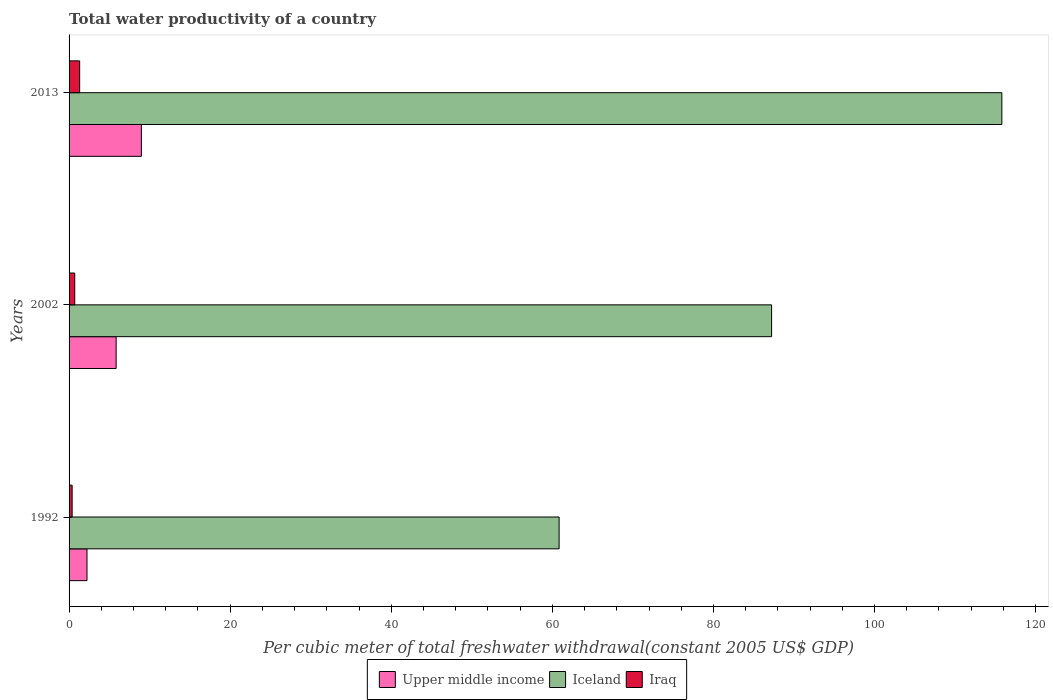How many groups of bars are there?
Your answer should be very brief. 3. Are the number of bars per tick equal to the number of legend labels?
Keep it short and to the point. Yes. Are the number of bars on each tick of the Y-axis equal?
Offer a terse response. Yes. How many bars are there on the 3rd tick from the top?
Ensure brevity in your answer.  3. What is the label of the 3rd group of bars from the top?
Your answer should be very brief. 1992. In how many cases, is the number of bars for a given year not equal to the number of legend labels?
Offer a terse response. 0. What is the total water productivity in Iraq in 2002?
Your answer should be very brief. 0.7. Across all years, what is the maximum total water productivity in Iraq?
Give a very brief answer. 1.31. Across all years, what is the minimum total water productivity in Iceland?
Your response must be concise. 60.84. In which year was the total water productivity in Iraq maximum?
Offer a terse response. 2013. What is the total total water productivity in Iceland in the graph?
Make the answer very short. 263.86. What is the difference between the total water productivity in Iceland in 1992 and that in 2002?
Provide a short and direct response. -26.38. What is the difference between the total water productivity in Iraq in 1992 and the total water productivity in Iceland in 2002?
Provide a succinct answer. -86.84. What is the average total water productivity in Iraq per year?
Offer a very short reply. 0.8. In the year 1992, what is the difference between the total water productivity in Iraq and total water productivity in Upper middle income?
Ensure brevity in your answer.  -1.85. In how many years, is the total water productivity in Iraq greater than 104 US$?
Offer a very short reply. 0. What is the ratio of the total water productivity in Upper middle income in 1992 to that in 2002?
Ensure brevity in your answer.  0.38. Is the total water productivity in Iraq in 1992 less than that in 2002?
Keep it short and to the point. Yes. What is the difference between the highest and the second highest total water productivity in Iceland?
Your response must be concise. 28.59. What is the difference between the highest and the lowest total water productivity in Iceland?
Make the answer very short. 54.97. What does the 2nd bar from the bottom in 1992 represents?
Make the answer very short. Iceland. Is it the case that in every year, the sum of the total water productivity in Iraq and total water productivity in Iceland is greater than the total water productivity in Upper middle income?
Provide a short and direct response. Yes. Are all the bars in the graph horizontal?
Provide a succinct answer. Yes. How many years are there in the graph?
Your response must be concise. 3. Are the values on the major ticks of X-axis written in scientific E-notation?
Provide a short and direct response. No. Does the graph contain any zero values?
Your answer should be compact. No. How many legend labels are there?
Give a very brief answer. 3. How are the legend labels stacked?
Make the answer very short. Horizontal. What is the title of the graph?
Provide a short and direct response. Total water productivity of a country. What is the label or title of the X-axis?
Your answer should be very brief. Per cubic meter of total freshwater withdrawal(constant 2005 US$ GDP). What is the Per cubic meter of total freshwater withdrawal(constant 2005 US$ GDP) of Upper middle income in 1992?
Ensure brevity in your answer.  2.23. What is the Per cubic meter of total freshwater withdrawal(constant 2005 US$ GDP) in Iceland in 1992?
Ensure brevity in your answer.  60.84. What is the Per cubic meter of total freshwater withdrawal(constant 2005 US$ GDP) in Iraq in 1992?
Provide a succinct answer. 0.38. What is the Per cubic meter of total freshwater withdrawal(constant 2005 US$ GDP) in Upper middle income in 2002?
Keep it short and to the point. 5.84. What is the Per cubic meter of total freshwater withdrawal(constant 2005 US$ GDP) in Iceland in 2002?
Your response must be concise. 87.22. What is the Per cubic meter of total freshwater withdrawal(constant 2005 US$ GDP) of Iraq in 2002?
Provide a succinct answer. 0.7. What is the Per cubic meter of total freshwater withdrawal(constant 2005 US$ GDP) in Upper middle income in 2013?
Provide a short and direct response. 8.98. What is the Per cubic meter of total freshwater withdrawal(constant 2005 US$ GDP) in Iceland in 2013?
Your answer should be very brief. 115.81. What is the Per cubic meter of total freshwater withdrawal(constant 2005 US$ GDP) of Iraq in 2013?
Make the answer very short. 1.31. Across all years, what is the maximum Per cubic meter of total freshwater withdrawal(constant 2005 US$ GDP) in Upper middle income?
Offer a very short reply. 8.98. Across all years, what is the maximum Per cubic meter of total freshwater withdrawal(constant 2005 US$ GDP) of Iceland?
Make the answer very short. 115.81. Across all years, what is the maximum Per cubic meter of total freshwater withdrawal(constant 2005 US$ GDP) of Iraq?
Offer a very short reply. 1.31. Across all years, what is the minimum Per cubic meter of total freshwater withdrawal(constant 2005 US$ GDP) in Upper middle income?
Ensure brevity in your answer.  2.23. Across all years, what is the minimum Per cubic meter of total freshwater withdrawal(constant 2005 US$ GDP) of Iceland?
Provide a short and direct response. 60.84. Across all years, what is the minimum Per cubic meter of total freshwater withdrawal(constant 2005 US$ GDP) in Iraq?
Make the answer very short. 0.38. What is the total Per cubic meter of total freshwater withdrawal(constant 2005 US$ GDP) in Upper middle income in the graph?
Offer a terse response. 17.04. What is the total Per cubic meter of total freshwater withdrawal(constant 2005 US$ GDP) of Iceland in the graph?
Offer a terse response. 263.86. What is the total Per cubic meter of total freshwater withdrawal(constant 2005 US$ GDP) of Iraq in the graph?
Ensure brevity in your answer.  2.4. What is the difference between the Per cubic meter of total freshwater withdrawal(constant 2005 US$ GDP) in Upper middle income in 1992 and that in 2002?
Keep it short and to the point. -3.62. What is the difference between the Per cubic meter of total freshwater withdrawal(constant 2005 US$ GDP) of Iceland in 1992 and that in 2002?
Keep it short and to the point. -26.38. What is the difference between the Per cubic meter of total freshwater withdrawal(constant 2005 US$ GDP) in Iraq in 1992 and that in 2002?
Your answer should be compact. -0.32. What is the difference between the Per cubic meter of total freshwater withdrawal(constant 2005 US$ GDP) of Upper middle income in 1992 and that in 2013?
Your answer should be very brief. -6.75. What is the difference between the Per cubic meter of total freshwater withdrawal(constant 2005 US$ GDP) of Iceland in 1992 and that in 2013?
Give a very brief answer. -54.97. What is the difference between the Per cubic meter of total freshwater withdrawal(constant 2005 US$ GDP) in Iraq in 1992 and that in 2013?
Offer a terse response. -0.93. What is the difference between the Per cubic meter of total freshwater withdrawal(constant 2005 US$ GDP) of Upper middle income in 2002 and that in 2013?
Your answer should be very brief. -3.13. What is the difference between the Per cubic meter of total freshwater withdrawal(constant 2005 US$ GDP) of Iceland in 2002 and that in 2013?
Give a very brief answer. -28.59. What is the difference between the Per cubic meter of total freshwater withdrawal(constant 2005 US$ GDP) in Iraq in 2002 and that in 2013?
Your response must be concise. -0.61. What is the difference between the Per cubic meter of total freshwater withdrawal(constant 2005 US$ GDP) of Upper middle income in 1992 and the Per cubic meter of total freshwater withdrawal(constant 2005 US$ GDP) of Iceland in 2002?
Make the answer very short. -84.99. What is the difference between the Per cubic meter of total freshwater withdrawal(constant 2005 US$ GDP) in Upper middle income in 1992 and the Per cubic meter of total freshwater withdrawal(constant 2005 US$ GDP) in Iraq in 2002?
Your response must be concise. 1.52. What is the difference between the Per cubic meter of total freshwater withdrawal(constant 2005 US$ GDP) of Iceland in 1992 and the Per cubic meter of total freshwater withdrawal(constant 2005 US$ GDP) of Iraq in 2002?
Make the answer very short. 60.14. What is the difference between the Per cubic meter of total freshwater withdrawal(constant 2005 US$ GDP) of Upper middle income in 1992 and the Per cubic meter of total freshwater withdrawal(constant 2005 US$ GDP) of Iceland in 2013?
Give a very brief answer. -113.58. What is the difference between the Per cubic meter of total freshwater withdrawal(constant 2005 US$ GDP) in Upper middle income in 1992 and the Per cubic meter of total freshwater withdrawal(constant 2005 US$ GDP) in Iraq in 2013?
Ensure brevity in your answer.  0.91. What is the difference between the Per cubic meter of total freshwater withdrawal(constant 2005 US$ GDP) in Iceland in 1992 and the Per cubic meter of total freshwater withdrawal(constant 2005 US$ GDP) in Iraq in 2013?
Ensure brevity in your answer.  59.53. What is the difference between the Per cubic meter of total freshwater withdrawal(constant 2005 US$ GDP) in Upper middle income in 2002 and the Per cubic meter of total freshwater withdrawal(constant 2005 US$ GDP) in Iceland in 2013?
Your answer should be very brief. -109.96. What is the difference between the Per cubic meter of total freshwater withdrawal(constant 2005 US$ GDP) in Upper middle income in 2002 and the Per cubic meter of total freshwater withdrawal(constant 2005 US$ GDP) in Iraq in 2013?
Your answer should be very brief. 4.53. What is the difference between the Per cubic meter of total freshwater withdrawal(constant 2005 US$ GDP) of Iceland in 2002 and the Per cubic meter of total freshwater withdrawal(constant 2005 US$ GDP) of Iraq in 2013?
Keep it short and to the point. 85.9. What is the average Per cubic meter of total freshwater withdrawal(constant 2005 US$ GDP) of Upper middle income per year?
Give a very brief answer. 5.68. What is the average Per cubic meter of total freshwater withdrawal(constant 2005 US$ GDP) in Iceland per year?
Your response must be concise. 87.95. What is the average Per cubic meter of total freshwater withdrawal(constant 2005 US$ GDP) in Iraq per year?
Keep it short and to the point. 0.8. In the year 1992, what is the difference between the Per cubic meter of total freshwater withdrawal(constant 2005 US$ GDP) in Upper middle income and Per cubic meter of total freshwater withdrawal(constant 2005 US$ GDP) in Iceland?
Provide a short and direct response. -58.61. In the year 1992, what is the difference between the Per cubic meter of total freshwater withdrawal(constant 2005 US$ GDP) in Upper middle income and Per cubic meter of total freshwater withdrawal(constant 2005 US$ GDP) in Iraq?
Your response must be concise. 1.85. In the year 1992, what is the difference between the Per cubic meter of total freshwater withdrawal(constant 2005 US$ GDP) of Iceland and Per cubic meter of total freshwater withdrawal(constant 2005 US$ GDP) of Iraq?
Ensure brevity in your answer.  60.46. In the year 2002, what is the difference between the Per cubic meter of total freshwater withdrawal(constant 2005 US$ GDP) of Upper middle income and Per cubic meter of total freshwater withdrawal(constant 2005 US$ GDP) of Iceland?
Offer a terse response. -81.38. In the year 2002, what is the difference between the Per cubic meter of total freshwater withdrawal(constant 2005 US$ GDP) of Upper middle income and Per cubic meter of total freshwater withdrawal(constant 2005 US$ GDP) of Iraq?
Offer a terse response. 5.14. In the year 2002, what is the difference between the Per cubic meter of total freshwater withdrawal(constant 2005 US$ GDP) of Iceland and Per cubic meter of total freshwater withdrawal(constant 2005 US$ GDP) of Iraq?
Offer a terse response. 86.52. In the year 2013, what is the difference between the Per cubic meter of total freshwater withdrawal(constant 2005 US$ GDP) of Upper middle income and Per cubic meter of total freshwater withdrawal(constant 2005 US$ GDP) of Iceland?
Provide a short and direct response. -106.83. In the year 2013, what is the difference between the Per cubic meter of total freshwater withdrawal(constant 2005 US$ GDP) in Upper middle income and Per cubic meter of total freshwater withdrawal(constant 2005 US$ GDP) in Iraq?
Provide a succinct answer. 7.66. In the year 2013, what is the difference between the Per cubic meter of total freshwater withdrawal(constant 2005 US$ GDP) of Iceland and Per cubic meter of total freshwater withdrawal(constant 2005 US$ GDP) of Iraq?
Make the answer very short. 114.49. What is the ratio of the Per cubic meter of total freshwater withdrawal(constant 2005 US$ GDP) of Upper middle income in 1992 to that in 2002?
Make the answer very short. 0.38. What is the ratio of the Per cubic meter of total freshwater withdrawal(constant 2005 US$ GDP) in Iceland in 1992 to that in 2002?
Offer a terse response. 0.7. What is the ratio of the Per cubic meter of total freshwater withdrawal(constant 2005 US$ GDP) of Iraq in 1992 to that in 2002?
Your answer should be very brief. 0.54. What is the ratio of the Per cubic meter of total freshwater withdrawal(constant 2005 US$ GDP) in Upper middle income in 1992 to that in 2013?
Offer a terse response. 0.25. What is the ratio of the Per cubic meter of total freshwater withdrawal(constant 2005 US$ GDP) in Iceland in 1992 to that in 2013?
Your answer should be compact. 0.53. What is the ratio of the Per cubic meter of total freshwater withdrawal(constant 2005 US$ GDP) in Iraq in 1992 to that in 2013?
Give a very brief answer. 0.29. What is the ratio of the Per cubic meter of total freshwater withdrawal(constant 2005 US$ GDP) in Upper middle income in 2002 to that in 2013?
Keep it short and to the point. 0.65. What is the ratio of the Per cubic meter of total freshwater withdrawal(constant 2005 US$ GDP) in Iceland in 2002 to that in 2013?
Offer a terse response. 0.75. What is the ratio of the Per cubic meter of total freshwater withdrawal(constant 2005 US$ GDP) in Iraq in 2002 to that in 2013?
Ensure brevity in your answer.  0.54. What is the difference between the highest and the second highest Per cubic meter of total freshwater withdrawal(constant 2005 US$ GDP) of Upper middle income?
Offer a terse response. 3.13. What is the difference between the highest and the second highest Per cubic meter of total freshwater withdrawal(constant 2005 US$ GDP) of Iceland?
Make the answer very short. 28.59. What is the difference between the highest and the second highest Per cubic meter of total freshwater withdrawal(constant 2005 US$ GDP) in Iraq?
Your answer should be compact. 0.61. What is the difference between the highest and the lowest Per cubic meter of total freshwater withdrawal(constant 2005 US$ GDP) of Upper middle income?
Your response must be concise. 6.75. What is the difference between the highest and the lowest Per cubic meter of total freshwater withdrawal(constant 2005 US$ GDP) in Iceland?
Keep it short and to the point. 54.97. What is the difference between the highest and the lowest Per cubic meter of total freshwater withdrawal(constant 2005 US$ GDP) in Iraq?
Keep it short and to the point. 0.93. 